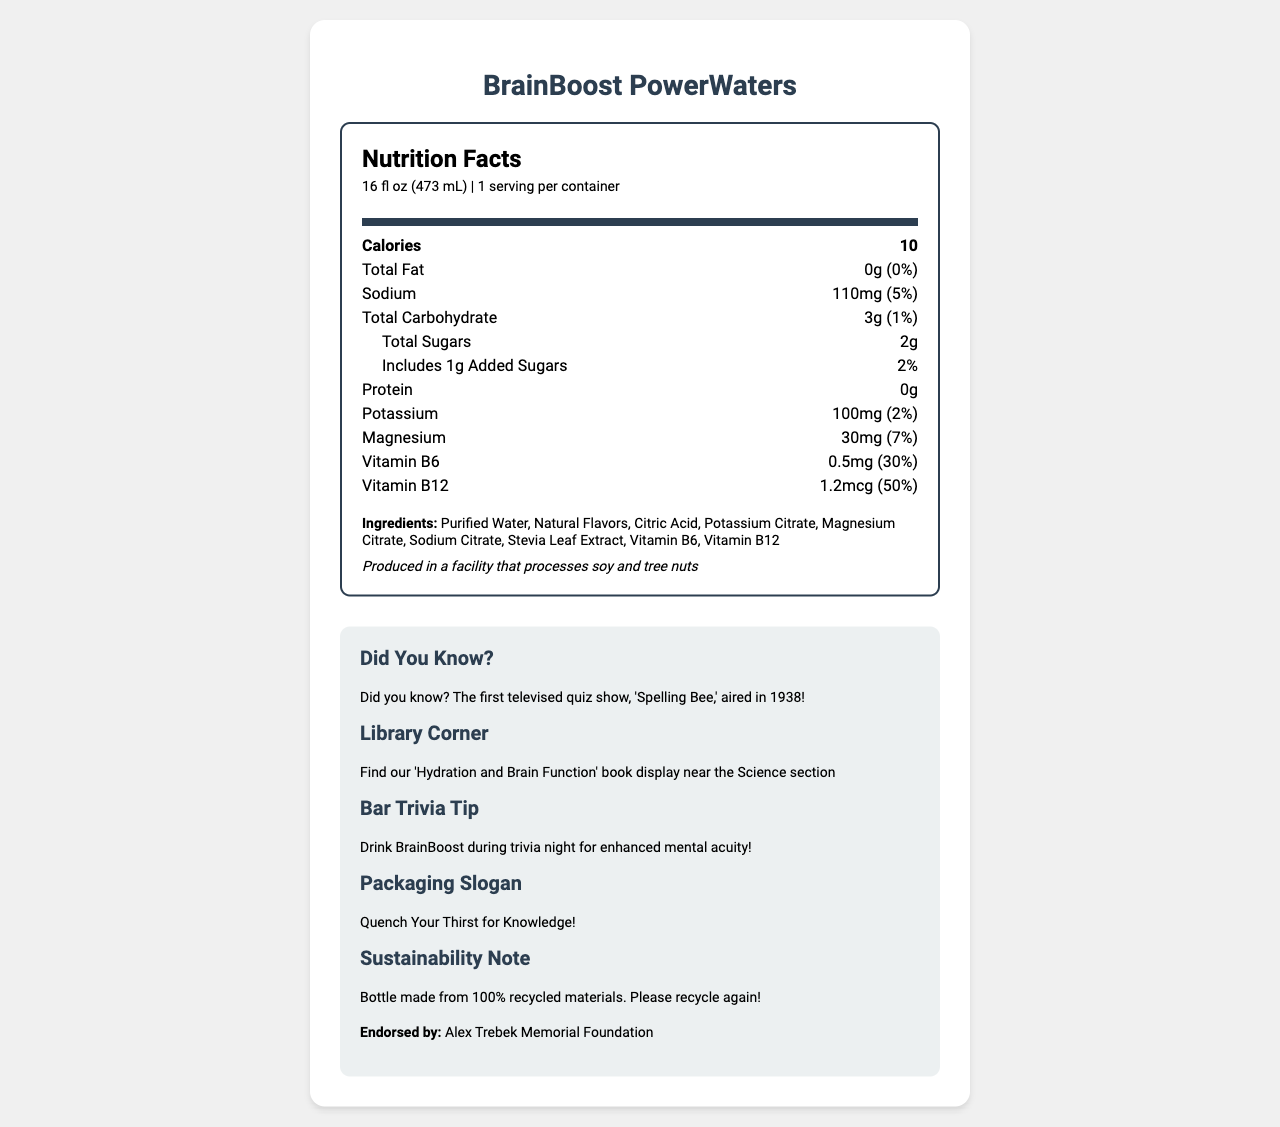what is the serving size of BrainBoost PowerWaters? The serving size is clearly mentioned at the top of the document: "16 fl oz (473 mL)".
Answer: 16 fl oz (473 mL) how many calories are in a serving of BrainBoost PowerWaters? The calories per serving are listed as 10 in the nutrition facts section.
Answer: 10 what are the total carbs in BrainBoost PowerWaters? The total carbohydrate content is listed as "3g" in the nutrition facts.
Answer: 3g how much Vitamin B12 is in BrainBoost PowerWaters? The nutrition facts list the amount of Vitamin B12 as "1.2mcg", which is 50% of the daily value.
Answer: 1.2mcg (50%) list the ingredients in BrainBoost PowerWaters. The ingredients are all listed under the "Ingredients" section of the document.
Answer: Purified Water, Natural Flavors, Citric Acid, Potassium Citrate, Magnesium Citrate, Sodium Citrate, Stevia Leaf Extract, Vitamin B6, Vitamin B12 which famous quiz show host's foundation endorses BrainBoost PowerWaters? A. Ken Jennings Memorial Foundation B. Alex Trebek Memorial Foundation C. Jeopardy! Contestants Foundation The document mentions "Endorsed by: Alex Trebek Memorial Foundation" in the extra-info section.
Answer: B how much sodium does one serving of BrainBoost PowerWaters contain? The amount of sodium is listed as "110mg", which is also 5% of the daily value according to the nutrition facts.
Answer: 110mg (5%) does BrainBoost PowerWaters contain any fat? The total fat content is listed as "0g", which implies that it contains no fat.
Answer: No which vitamin has the highest daily value percentage in BrainBoost PowerWaters? The daily value percentages for the vitamins are: B6 at 30% and B12 at 50%, so Vitamin B12 has the highest percentage.
Answer: Vitamin B12 is BrainBoost PowerWaters sustainable? The document states in the extra-info section: "Bottle made from 100% recycled materials. Please recycle again!"
Answer: Yes what is the summary of the extra information in BrainBoost PowerWaters document? The extra-info section includes trivia, a library recommendation, a bar trivia tip, the product slogan, sustainability note, and the endorsement.
Answer: The extra information highlights a trivia fact about the first televised quiz show, recommends the drink for enhanced mental acuity during trivia nights, features a hydration-related book display in a library, has a slogan "Quench Your Thirst for Knowledge!", and notes that the bottle is made from 100% recycled materials. The product is endorsed by the Alex Trebek Memorial Foundation. how much protein does BrainBoost PowerWaters have? A. 0g B. 1g C. 2g D. 3g The document states the protein content is "0g".
Answer: A how much magnesium is in BrainBoost PowerWaters? The nutrition facts list the magnesium content as "30mg", which is 7% of the daily value.
Answer: 30mg (7%) who produces BrainBoost PowerWaters? The document does not provide information about the producer or manufacturer of BrainBoost PowerWaters.
Answer: Not enough information 